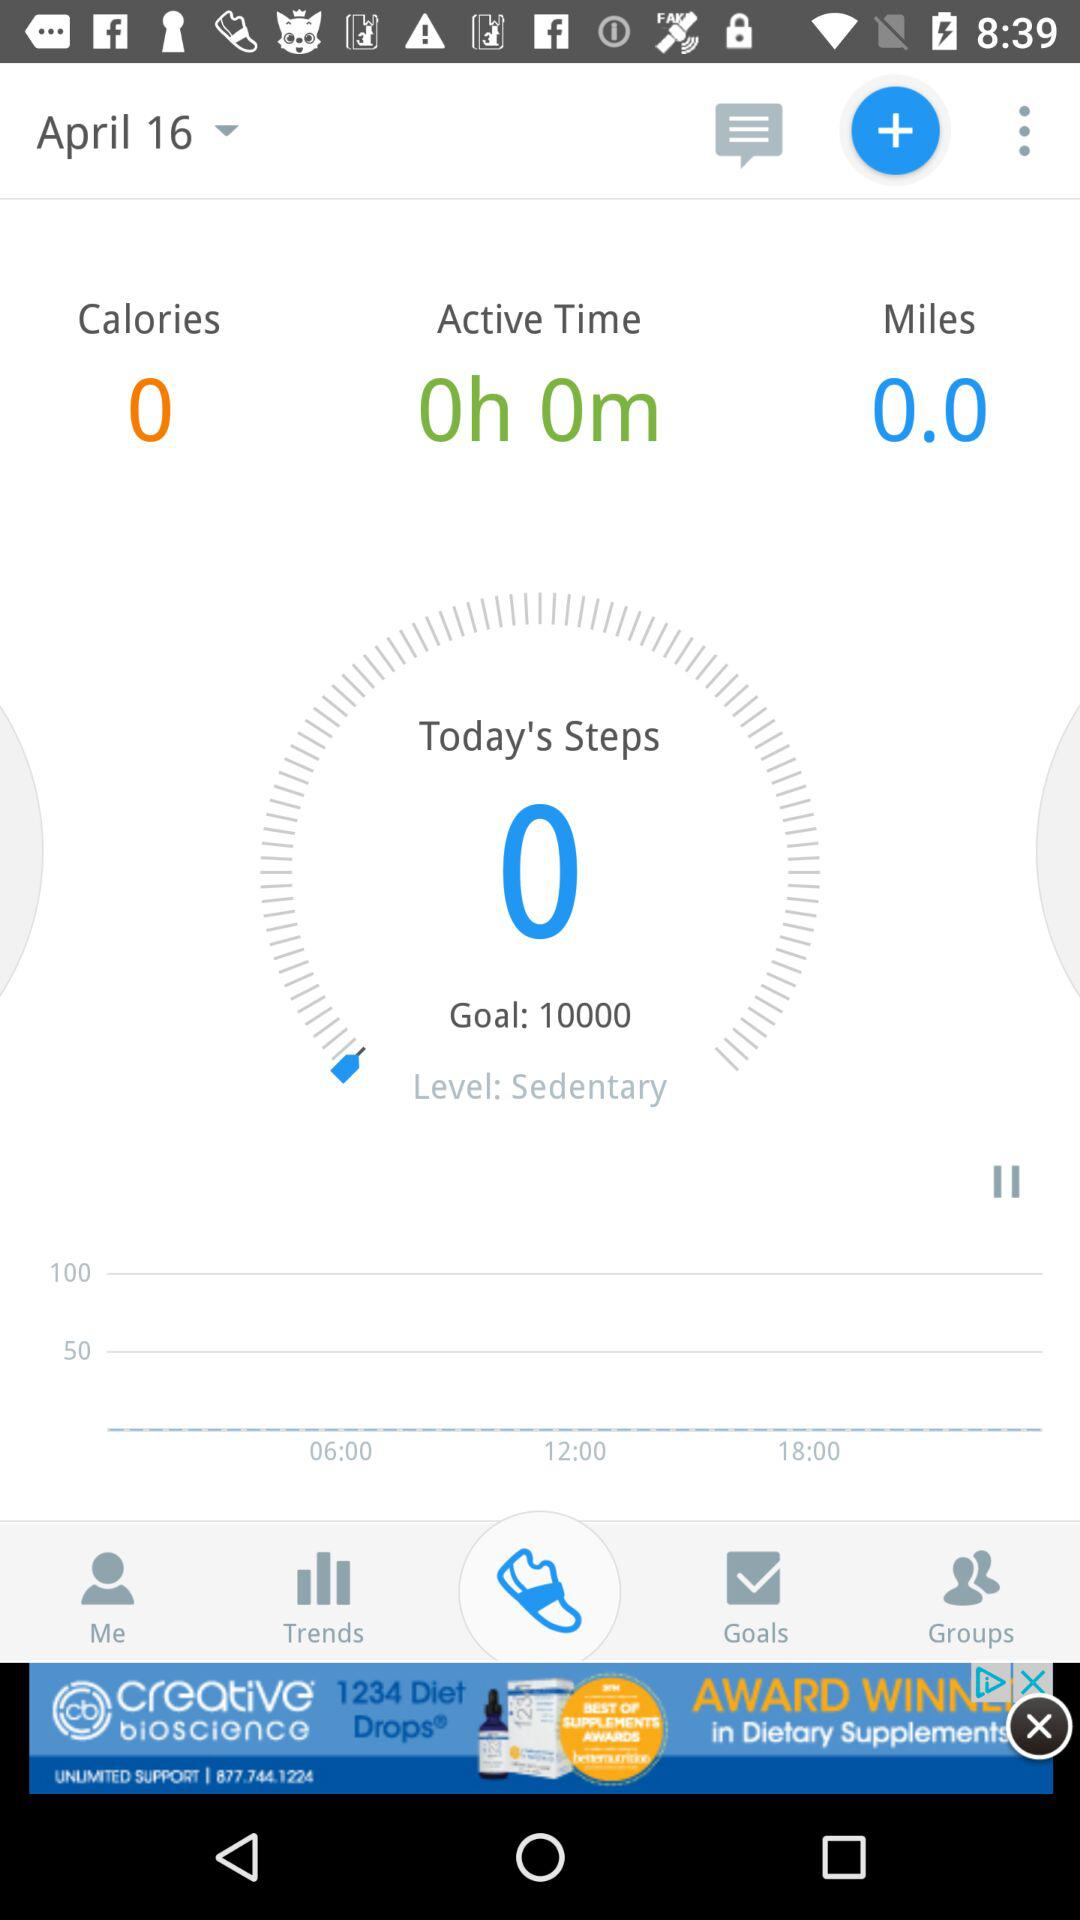What goal is set for the total number of steps? The goal set for the total number of steps is 10,000. 